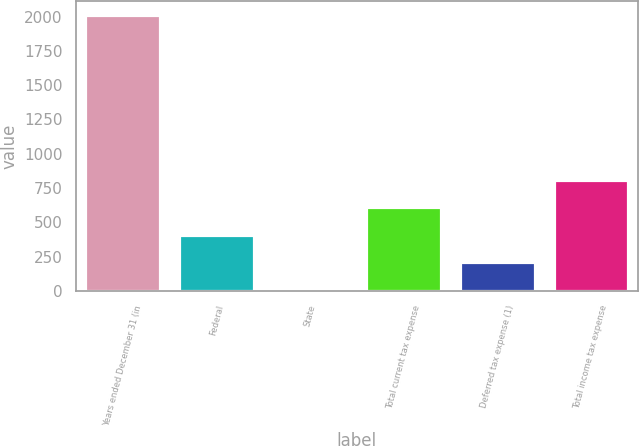<chart> <loc_0><loc_0><loc_500><loc_500><bar_chart><fcel>Years ended December 31 (in<fcel>Federal<fcel>State<fcel>Total current tax expense<fcel>Deferred tax expense (1)<fcel>Total income tax expense<nl><fcel>2013<fcel>410.44<fcel>9.8<fcel>610.76<fcel>210.12<fcel>811.08<nl></chart> 